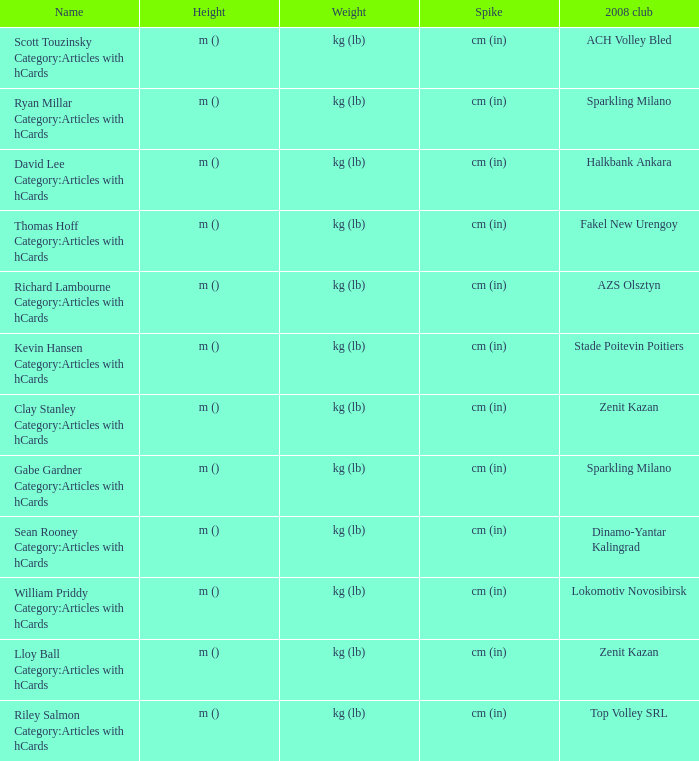What is the name for the 2008 club of Azs olsztyn? Richard Lambourne Category:Articles with hCards. 